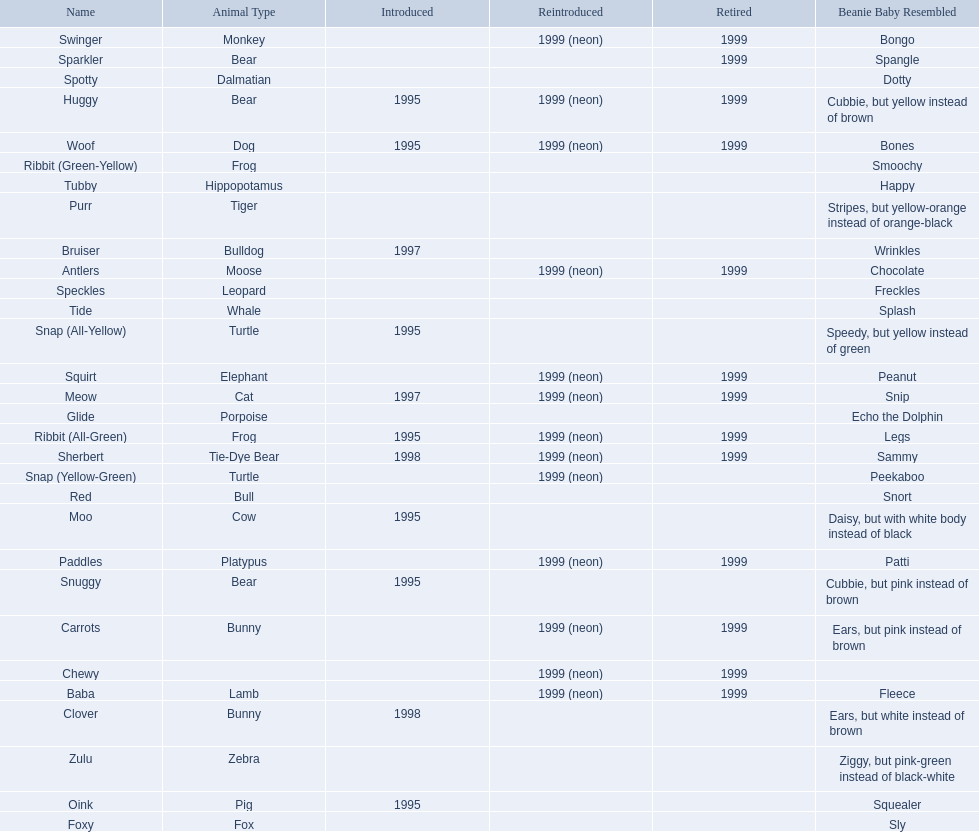Would you be able to parse every entry in this table? {'header': ['Name', 'Animal Type', 'Introduced', 'Reintroduced', 'Retired', 'Beanie Baby Resembled'], 'rows': [['Swinger', 'Monkey', '', '1999 (neon)', '1999', 'Bongo'], ['Sparkler', 'Bear', '', '', '1999', 'Spangle'], ['Spotty', 'Dalmatian', '', '', '', 'Dotty'], ['Huggy', 'Bear', '1995', '1999 (neon)', '1999', 'Cubbie, but yellow instead of brown'], ['Woof', 'Dog', '1995', '1999 (neon)', '1999', 'Bones'], ['Ribbit (Green-Yellow)', 'Frog', '', '', '', 'Smoochy'], ['Tubby', 'Hippopotamus', '', '', '', 'Happy'], ['Purr', 'Tiger', '', '', '', 'Stripes, but yellow-orange instead of orange-black'], ['Bruiser', 'Bulldog', '1997', '', '', 'Wrinkles'], ['Antlers', 'Moose', '', '1999 (neon)', '1999', 'Chocolate'], ['Speckles', 'Leopard', '', '', '', 'Freckles'], ['Tide', 'Whale', '', '', '', 'Splash'], ['Snap (All-Yellow)', 'Turtle', '1995', '', '', 'Speedy, but yellow instead of green'], ['Squirt', 'Elephant', '', '1999 (neon)', '1999', 'Peanut'], ['Meow', 'Cat', '1997', '1999 (neon)', '1999', 'Snip'], ['Glide', 'Porpoise', '', '', '', 'Echo the Dolphin'], ['Ribbit (All-Green)', 'Frog', '1995', '1999 (neon)', '1999', 'Legs'], ['Sherbert', 'Tie-Dye Bear', '1998', '1999 (neon)', '1999', 'Sammy'], ['Snap (Yellow-Green)', 'Turtle', '', '1999 (neon)', '', 'Peekaboo'], ['Red', 'Bull', '', '', '', 'Snort'], ['Moo', 'Cow', '1995', '', '', 'Daisy, but with white body instead of black'], ['Paddles', 'Platypus', '', '1999 (neon)', '1999', 'Patti'], ['Snuggy', 'Bear', '1995', '', '', 'Cubbie, but pink instead of brown'], ['Carrots', 'Bunny', '', '1999 (neon)', '1999', 'Ears, but pink instead of brown'], ['Chewy', '', '', '1999 (neon)', '1999', ''], ['Baba', 'Lamb', '', '1999 (neon)', '1999', 'Fleece'], ['Clover', 'Bunny', '1998', '', '', 'Ears, but white instead of brown'], ['Zulu', 'Zebra', '', '', '', 'Ziggy, but pink-green instead of black-white'], ['Oink', 'Pig', '1995', '', '', 'Squealer'], ['Foxy', 'Fox', '', '', '', 'Sly']]} What are the names listed? Antlers, Baba, Bruiser, Carrots, Chewy, Clover, Foxy, Glide, Huggy, Meow, Moo, Oink, Paddles, Purr, Red, Ribbit (All-Green), Ribbit (Green-Yellow), Sherbert, Snap (All-Yellow), Snap (Yellow-Green), Snuggy, Sparkler, Speckles, Spotty, Squirt, Swinger, Tide, Tubby, Woof, Zulu. Of these, which is the only pet without an animal type listed? Chewy. 